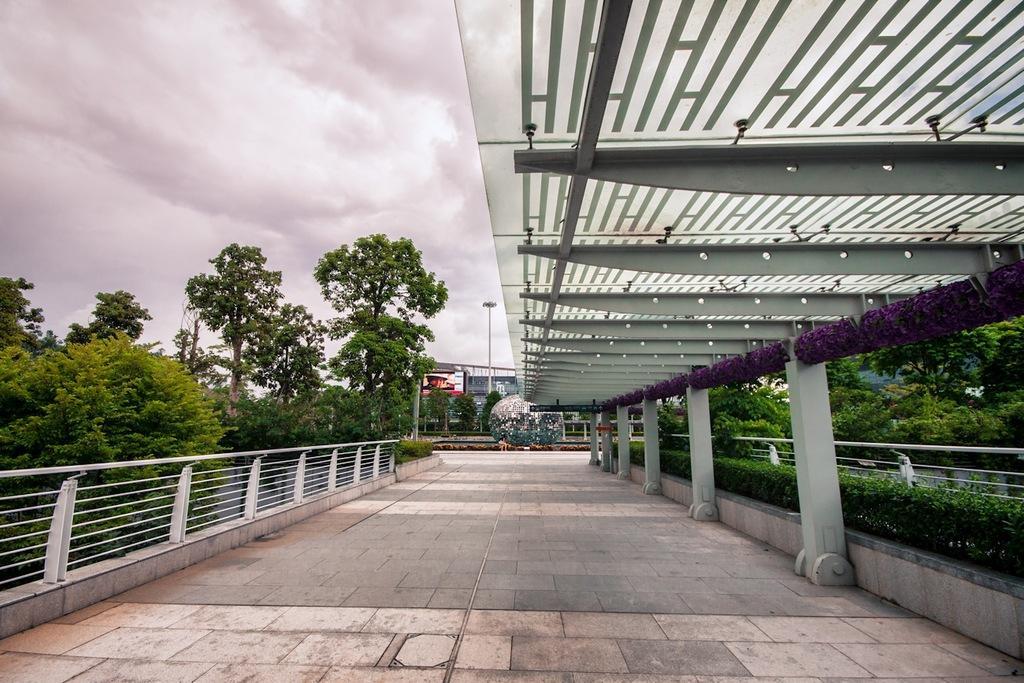Can you describe this image briefly? In this image, we can see trees, buildings, pole and there is a hedge. At the bottom, we can see paving blocks. 